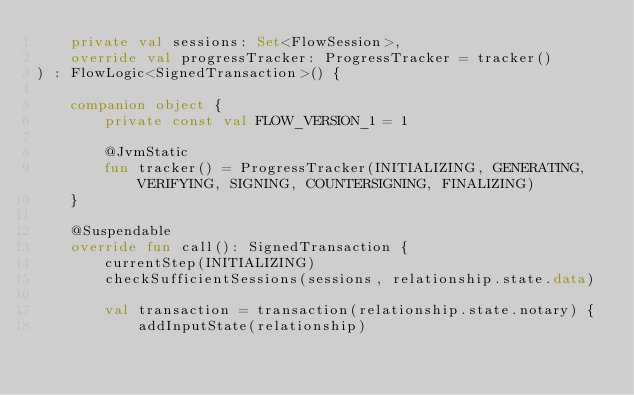<code> <loc_0><loc_0><loc_500><loc_500><_Kotlin_>    private val sessions: Set<FlowSession>,
    override val progressTracker: ProgressTracker = tracker()
) : FlowLogic<SignedTransaction>() {

    companion object {
        private const val FLOW_VERSION_1 = 1

        @JvmStatic
        fun tracker() = ProgressTracker(INITIALIZING, GENERATING, VERIFYING, SIGNING, COUNTERSIGNING, FINALIZING)
    }

    @Suspendable
    override fun call(): SignedTransaction {
        currentStep(INITIALIZING)
        checkSufficientSessions(sessions, relationship.state.data)

        val transaction = transaction(relationship.state.notary) {
            addInputState(relationship)</code> 